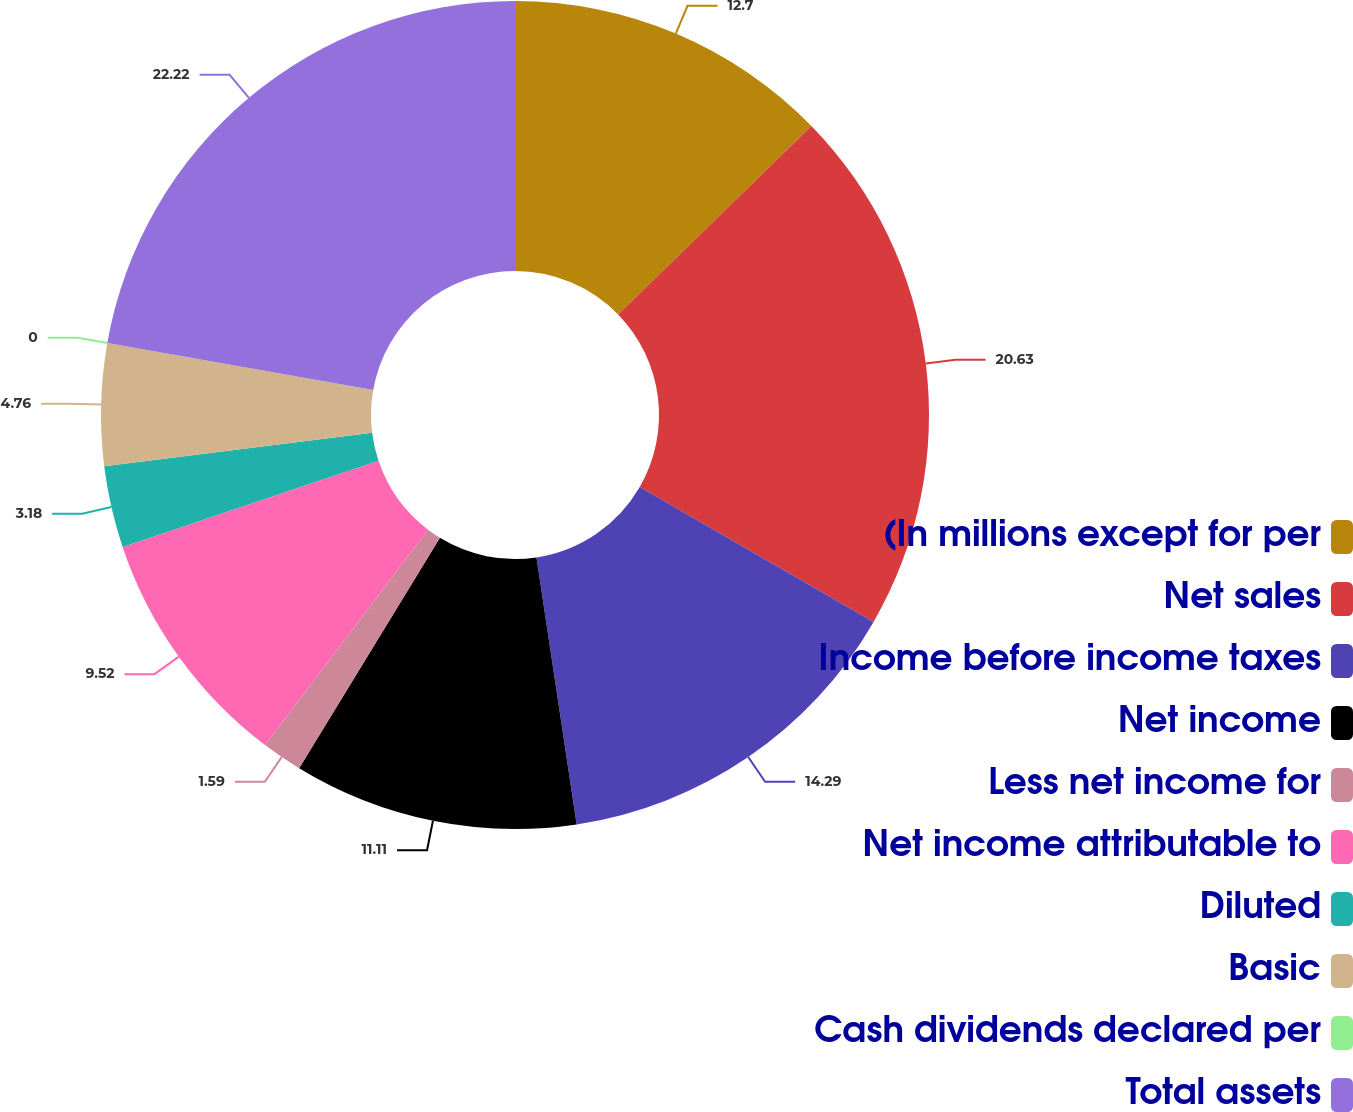<chart> <loc_0><loc_0><loc_500><loc_500><pie_chart><fcel>(In millions except for per<fcel>Net sales<fcel>Income before income taxes<fcel>Net income<fcel>Less net income for<fcel>Net income attributable to<fcel>Diluted<fcel>Basic<fcel>Cash dividends declared per<fcel>Total assets<nl><fcel>12.7%<fcel>20.63%<fcel>14.29%<fcel>11.11%<fcel>1.59%<fcel>9.52%<fcel>3.18%<fcel>4.76%<fcel>0.0%<fcel>22.22%<nl></chart> 